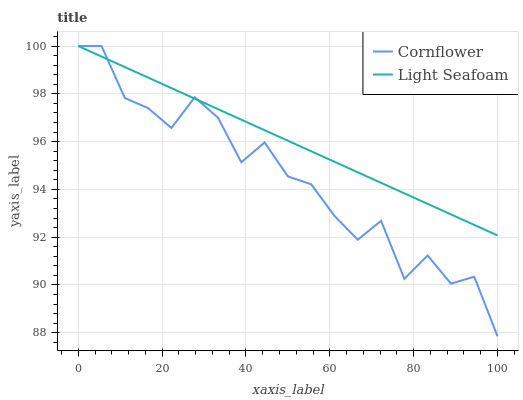Does Cornflower have the minimum area under the curve?
Answer yes or no. Yes. Does Light Seafoam have the maximum area under the curve?
Answer yes or no. Yes. Does Light Seafoam have the minimum area under the curve?
Answer yes or no. No. Is Light Seafoam the smoothest?
Answer yes or no. Yes. Is Cornflower the roughest?
Answer yes or no. Yes. Is Light Seafoam the roughest?
Answer yes or no. No. Does Cornflower have the lowest value?
Answer yes or no. Yes. Does Light Seafoam have the lowest value?
Answer yes or no. No. Does Light Seafoam have the highest value?
Answer yes or no. Yes. Does Cornflower intersect Light Seafoam?
Answer yes or no. Yes. Is Cornflower less than Light Seafoam?
Answer yes or no. No. Is Cornflower greater than Light Seafoam?
Answer yes or no. No. 